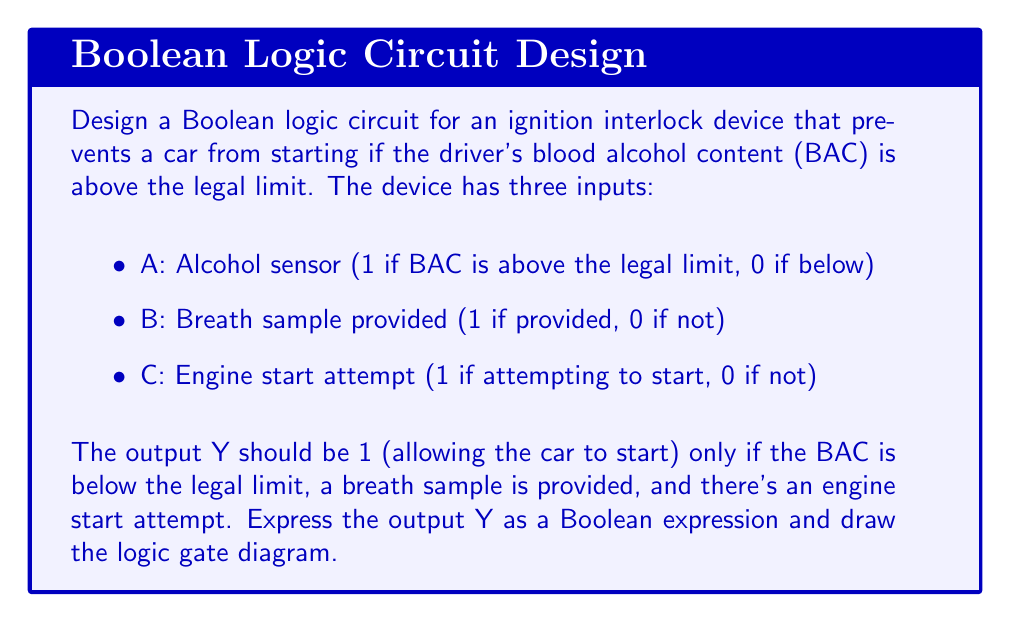Can you answer this question? Step 1: Determine the truth table for the ignition interlock device.

A | B | C | Y
0 | 1 | 1 | 1 (Car starts: BAC below limit, sample provided, start attempted)
All other combinations | 0 (Car doesn't start)

Step 2: Express the output Y as a Boolean expression.
Y will be 1 only when A is 0 (BAC below limit), B is 1 (sample provided), and C is 1 (start attempted).
This can be written as: $Y = \overline{A} \cdot B \cdot C$

Step 3: Simplify the expression (if possible).
The expression is already in its simplest form.

Step 4: Draw the logic gate diagram.
[asy]
import geometry;

pair A = (0,80), B = (0,50), C = (0,20);
pair notA = (50,80);
pair and1 = (100,65);
pair and2 = (150,50);
pair Y = (200,50);

draw(A--notA);
draw(notA--and1);
draw(B--(50,50)--(100,50));
draw(C--(100,35));
draw(and1--and2);
draw((100,35)--(150,35));
draw(and2--Y);

label("A", A, W);
label("B", B, W);
label("C", C, W);
label("Y", Y, E);

dot(A); dot(B); dot(C); dot(Y);

draw(circle(notA,5));
draw(box((95,70),(105,60)));
draw(box((145,55),(155,45)));

label("1", (97.5,65));
label("&", (150,50));
[/asy]

The diagram shows:
1. Input A goes through a NOT gate (inverter).
2. The output of the NOT gate, along with inputs B and C, are connected to an AND gate with three inputs.
3. The output of this AND gate is Y, which controls whether the car can start.

This circuit ensures that the car will only start (Y = 1) when the BAC is below the legal limit (A = 0), a breath sample is provided (B = 1), and there's an engine start attempt (C = 1).
Answer: $Y = \overline{A} \cdot B \cdot C$ 